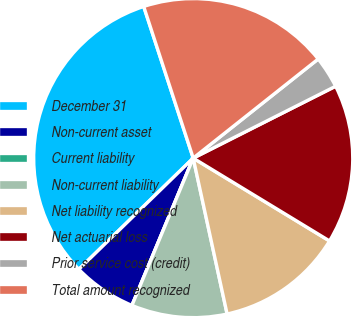Convert chart. <chart><loc_0><loc_0><loc_500><loc_500><pie_chart><fcel>December 31<fcel>Non-current asset<fcel>Current liability<fcel>Non-current liability<fcel>Net liability recognized<fcel>Net actuarial loss<fcel>Prior service cost (credit)<fcel>Total amount recognized<nl><fcel>32.25%<fcel>6.45%<fcel>0.0%<fcel>9.68%<fcel>12.9%<fcel>16.13%<fcel>3.23%<fcel>19.35%<nl></chart> 